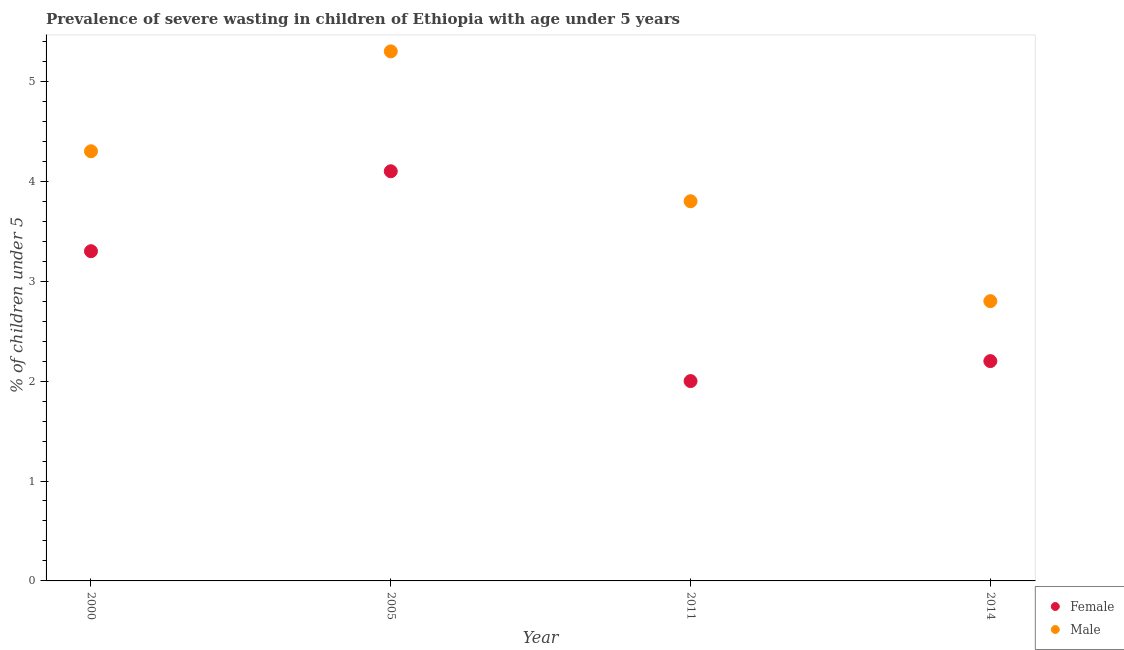How many different coloured dotlines are there?
Keep it short and to the point. 2. Is the number of dotlines equal to the number of legend labels?
Your response must be concise. Yes. What is the percentage of undernourished female children in 2005?
Ensure brevity in your answer.  4.1. Across all years, what is the maximum percentage of undernourished male children?
Offer a very short reply. 5.3. In which year was the percentage of undernourished female children minimum?
Ensure brevity in your answer.  2011. What is the total percentage of undernourished female children in the graph?
Give a very brief answer. 11.6. What is the difference between the percentage of undernourished male children in 2000 and that in 2014?
Your answer should be very brief. 1.5. What is the difference between the percentage of undernourished female children in 2000 and the percentage of undernourished male children in 2005?
Your answer should be compact. -2. What is the average percentage of undernourished male children per year?
Offer a very short reply. 4.05. In the year 2014, what is the difference between the percentage of undernourished male children and percentage of undernourished female children?
Keep it short and to the point. 0.6. In how many years, is the percentage of undernourished female children greater than 2.6 %?
Your answer should be very brief. 2. What is the ratio of the percentage of undernourished female children in 2005 to that in 2014?
Make the answer very short. 1.86. What is the difference between the highest and the second highest percentage of undernourished female children?
Provide a succinct answer. 0.8. What is the difference between the highest and the lowest percentage of undernourished female children?
Offer a terse response. 2.1. In how many years, is the percentage of undernourished male children greater than the average percentage of undernourished male children taken over all years?
Ensure brevity in your answer.  2. Is the sum of the percentage of undernourished female children in 2000 and 2005 greater than the maximum percentage of undernourished male children across all years?
Make the answer very short. Yes. Is the percentage of undernourished male children strictly greater than the percentage of undernourished female children over the years?
Give a very brief answer. Yes. Is the percentage of undernourished male children strictly less than the percentage of undernourished female children over the years?
Ensure brevity in your answer.  No. How many dotlines are there?
Provide a short and direct response. 2. How many years are there in the graph?
Provide a short and direct response. 4. What is the difference between two consecutive major ticks on the Y-axis?
Provide a short and direct response. 1. Does the graph contain any zero values?
Your answer should be very brief. No. Does the graph contain grids?
Provide a succinct answer. No. Where does the legend appear in the graph?
Ensure brevity in your answer.  Bottom right. How are the legend labels stacked?
Give a very brief answer. Vertical. What is the title of the graph?
Your answer should be very brief. Prevalence of severe wasting in children of Ethiopia with age under 5 years. What is the label or title of the Y-axis?
Provide a short and direct response.  % of children under 5. What is the  % of children under 5 of Female in 2000?
Keep it short and to the point. 3.3. What is the  % of children under 5 of Male in 2000?
Give a very brief answer. 4.3. What is the  % of children under 5 of Female in 2005?
Offer a terse response. 4.1. What is the  % of children under 5 in Male in 2005?
Ensure brevity in your answer.  5.3. What is the  % of children under 5 of Female in 2011?
Give a very brief answer. 2. What is the  % of children under 5 in Male in 2011?
Offer a very short reply. 3.8. What is the  % of children under 5 in Female in 2014?
Keep it short and to the point. 2.2. What is the  % of children under 5 in Male in 2014?
Offer a terse response. 2.8. Across all years, what is the maximum  % of children under 5 in Female?
Your answer should be very brief. 4.1. Across all years, what is the maximum  % of children under 5 in Male?
Your response must be concise. 5.3. Across all years, what is the minimum  % of children under 5 of Female?
Ensure brevity in your answer.  2. Across all years, what is the minimum  % of children under 5 in Male?
Your answer should be compact. 2.8. What is the difference between the  % of children under 5 in Female in 2000 and that in 2005?
Make the answer very short. -0.8. What is the difference between the  % of children under 5 of Male in 2000 and that in 2005?
Offer a terse response. -1. What is the difference between the  % of children under 5 in Female in 2000 and that in 2011?
Ensure brevity in your answer.  1.3. What is the difference between the  % of children under 5 of Male in 2005 and that in 2011?
Your answer should be very brief. 1.5. What is the difference between the  % of children under 5 in Male in 2005 and that in 2014?
Your response must be concise. 2.5. What is the difference between the  % of children under 5 in Female in 2011 and that in 2014?
Give a very brief answer. -0.2. What is the difference between the  % of children under 5 of Male in 2011 and that in 2014?
Ensure brevity in your answer.  1. What is the difference between the  % of children under 5 in Female in 2000 and the  % of children under 5 in Male in 2005?
Give a very brief answer. -2. What is the difference between the  % of children under 5 in Female in 2005 and the  % of children under 5 in Male in 2011?
Your answer should be compact. 0.3. What is the difference between the  % of children under 5 in Female in 2005 and the  % of children under 5 in Male in 2014?
Offer a very short reply. 1.3. What is the difference between the  % of children under 5 in Female in 2011 and the  % of children under 5 in Male in 2014?
Provide a short and direct response. -0.8. What is the average  % of children under 5 of Male per year?
Give a very brief answer. 4.05. In the year 2005, what is the difference between the  % of children under 5 of Female and  % of children under 5 of Male?
Keep it short and to the point. -1.2. In the year 2011, what is the difference between the  % of children under 5 in Female and  % of children under 5 in Male?
Keep it short and to the point. -1.8. What is the ratio of the  % of children under 5 in Female in 2000 to that in 2005?
Give a very brief answer. 0.8. What is the ratio of the  % of children under 5 in Male in 2000 to that in 2005?
Give a very brief answer. 0.81. What is the ratio of the  % of children under 5 of Female in 2000 to that in 2011?
Keep it short and to the point. 1.65. What is the ratio of the  % of children under 5 of Male in 2000 to that in 2011?
Provide a succinct answer. 1.13. What is the ratio of the  % of children under 5 in Female in 2000 to that in 2014?
Provide a succinct answer. 1.5. What is the ratio of the  % of children under 5 in Male in 2000 to that in 2014?
Offer a very short reply. 1.54. What is the ratio of the  % of children under 5 of Female in 2005 to that in 2011?
Your response must be concise. 2.05. What is the ratio of the  % of children under 5 of Male in 2005 to that in 2011?
Offer a terse response. 1.39. What is the ratio of the  % of children under 5 of Female in 2005 to that in 2014?
Provide a short and direct response. 1.86. What is the ratio of the  % of children under 5 of Male in 2005 to that in 2014?
Offer a terse response. 1.89. What is the ratio of the  % of children under 5 of Female in 2011 to that in 2014?
Give a very brief answer. 0.91. What is the ratio of the  % of children under 5 of Male in 2011 to that in 2014?
Offer a terse response. 1.36. What is the difference between the highest and the second highest  % of children under 5 of Female?
Ensure brevity in your answer.  0.8. What is the difference between the highest and the lowest  % of children under 5 of Female?
Give a very brief answer. 2.1. What is the difference between the highest and the lowest  % of children under 5 in Male?
Keep it short and to the point. 2.5. 